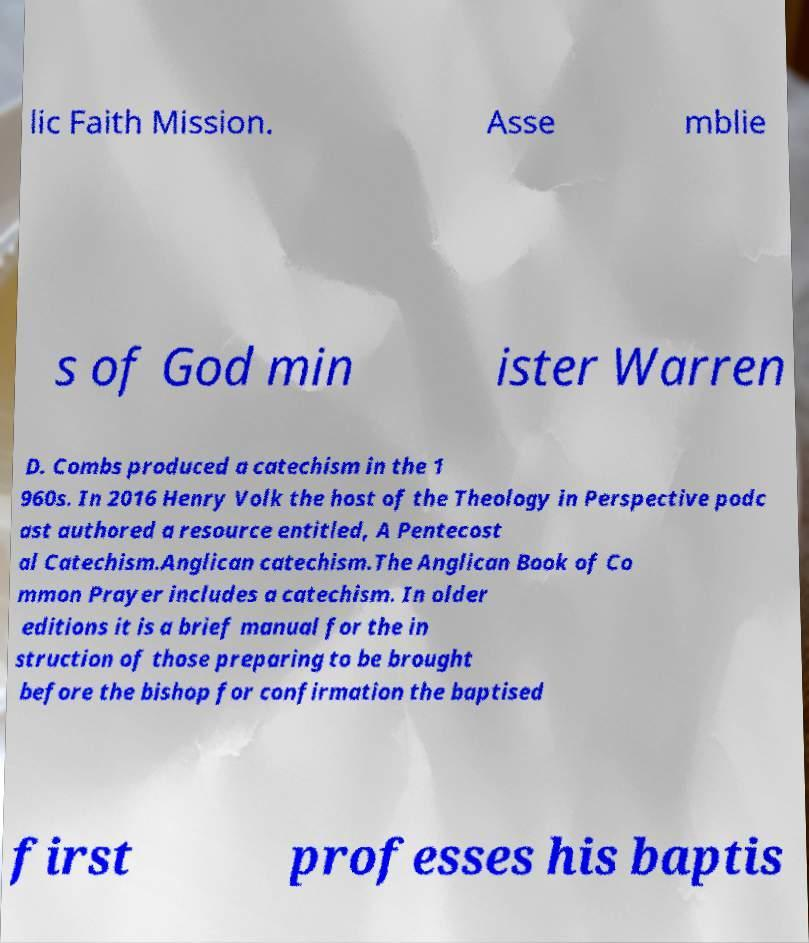Please identify and transcribe the text found in this image. lic Faith Mission. Asse mblie s of God min ister Warren D. Combs produced a catechism in the 1 960s. In 2016 Henry Volk the host of the Theology in Perspective podc ast authored a resource entitled, A Pentecost al Catechism.Anglican catechism.The Anglican Book of Co mmon Prayer includes a catechism. In older editions it is a brief manual for the in struction of those preparing to be brought before the bishop for confirmation the baptised first professes his baptis 